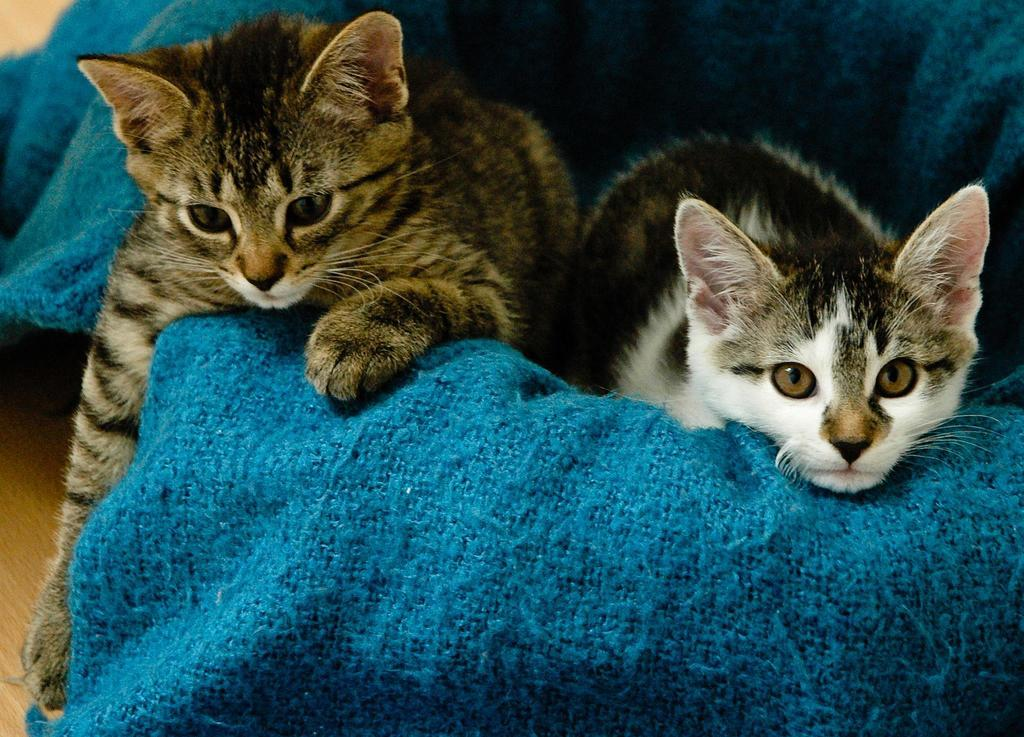What animals are in the center of the image? There are two cats in the center of the image. What can be seen in the background of the image? There is cloth in the background of the image. What is at the bottom of the image? The floor is present at the bottom of the image. What type of salt is being used by the cats in the image? There is no salt present in the image; it features two cats and a cloth background. What type of school can be seen in the image? There is no school present in the image; it features two cats and a cloth background. 